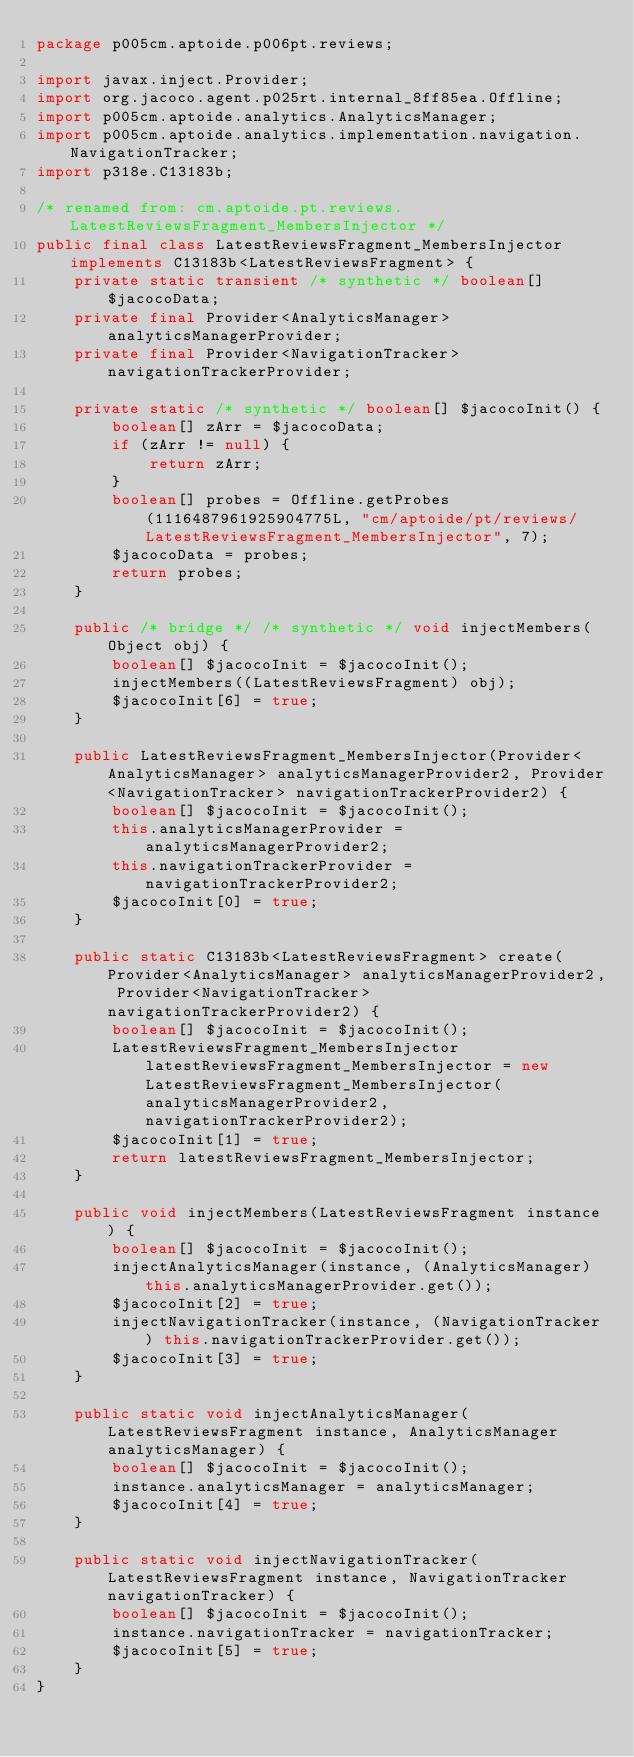<code> <loc_0><loc_0><loc_500><loc_500><_Java_>package p005cm.aptoide.p006pt.reviews;

import javax.inject.Provider;
import org.jacoco.agent.p025rt.internal_8ff85ea.Offline;
import p005cm.aptoide.analytics.AnalyticsManager;
import p005cm.aptoide.analytics.implementation.navigation.NavigationTracker;
import p318e.C13183b;

/* renamed from: cm.aptoide.pt.reviews.LatestReviewsFragment_MembersInjector */
public final class LatestReviewsFragment_MembersInjector implements C13183b<LatestReviewsFragment> {
    private static transient /* synthetic */ boolean[] $jacocoData;
    private final Provider<AnalyticsManager> analyticsManagerProvider;
    private final Provider<NavigationTracker> navigationTrackerProvider;

    private static /* synthetic */ boolean[] $jacocoInit() {
        boolean[] zArr = $jacocoData;
        if (zArr != null) {
            return zArr;
        }
        boolean[] probes = Offline.getProbes(1116487961925904775L, "cm/aptoide/pt/reviews/LatestReviewsFragment_MembersInjector", 7);
        $jacocoData = probes;
        return probes;
    }

    public /* bridge */ /* synthetic */ void injectMembers(Object obj) {
        boolean[] $jacocoInit = $jacocoInit();
        injectMembers((LatestReviewsFragment) obj);
        $jacocoInit[6] = true;
    }

    public LatestReviewsFragment_MembersInjector(Provider<AnalyticsManager> analyticsManagerProvider2, Provider<NavigationTracker> navigationTrackerProvider2) {
        boolean[] $jacocoInit = $jacocoInit();
        this.analyticsManagerProvider = analyticsManagerProvider2;
        this.navigationTrackerProvider = navigationTrackerProvider2;
        $jacocoInit[0] = true;
    }

    public static C13183b<LatestReviewsFragment> create(Provider<AnalyticsManager> analyticsManagerProvider2, Provider<NavigationTracker> navigationTrackerProvider2) {
        boolean[] $jacocoInit = $jacocoInit();
        LatestReviewsFragment_MembersInjector latestReviewsFragment_MembersInjector = new LatestReviewsFragment_MembersInjector(analyticsManagerProvider2, navigationTrackerProvider2);
        $jacocoInit[1] = true;
        return latestReviewsFragment_MembersInjector;
    }

    public void injectMembers(LatestReviewsFragment instance) {
        boolean[] $jacocoInit = $jacocoInit();
        injectAnalyticsManager(instance, (AnalyticsManager) this.analyticsManagerProvider.get());
        $jacocoInit[2] = true;
        injectNavigationTracker(instance, (NavigationTracker) this.navigationTrackerProvider.get());
        $jacocoInit[3] = true;
    }

    public static void injectAnalyticsManager(LatestReviewsFragment instance, AnalyticsManager analyticsManager) {
        boolean[] $jacocoInit = $jacocoInit();
        instance.analyticsManager = analyticsManager;
        $jacocoInit[4] = true;
    }

    public static void injectNavigationTracker(LatestReviewsFragment instance, NavigationTracker navigationTracker) {
        boolean[] $jacocoInit = $jacocoInit();
        instance.navigationTracker = navigationTracker;
        $jacocoInit[5] = true;
    }
}
</code> 